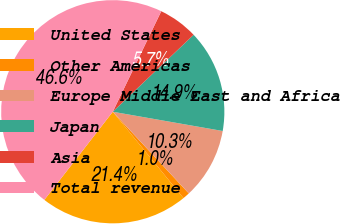<chart> <loc_0><loc_0><loc_500><loc_500><pie_chart><fcel>United States<fcel>Other Americas<fcel>Europe Middle East and Africa<fcel>Japan<fcel>Asia<fcel>Total revenue<nl><fcel>21.43%<fcel>1.01%<fcel>10.31%<fcel>14.87%<fcel>5.74%<fcel>46.65%<nl></chart> 